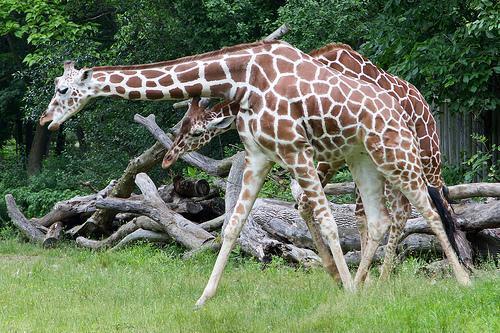How many giraffes have their mouth open?
Give a very brief answer. 1. 